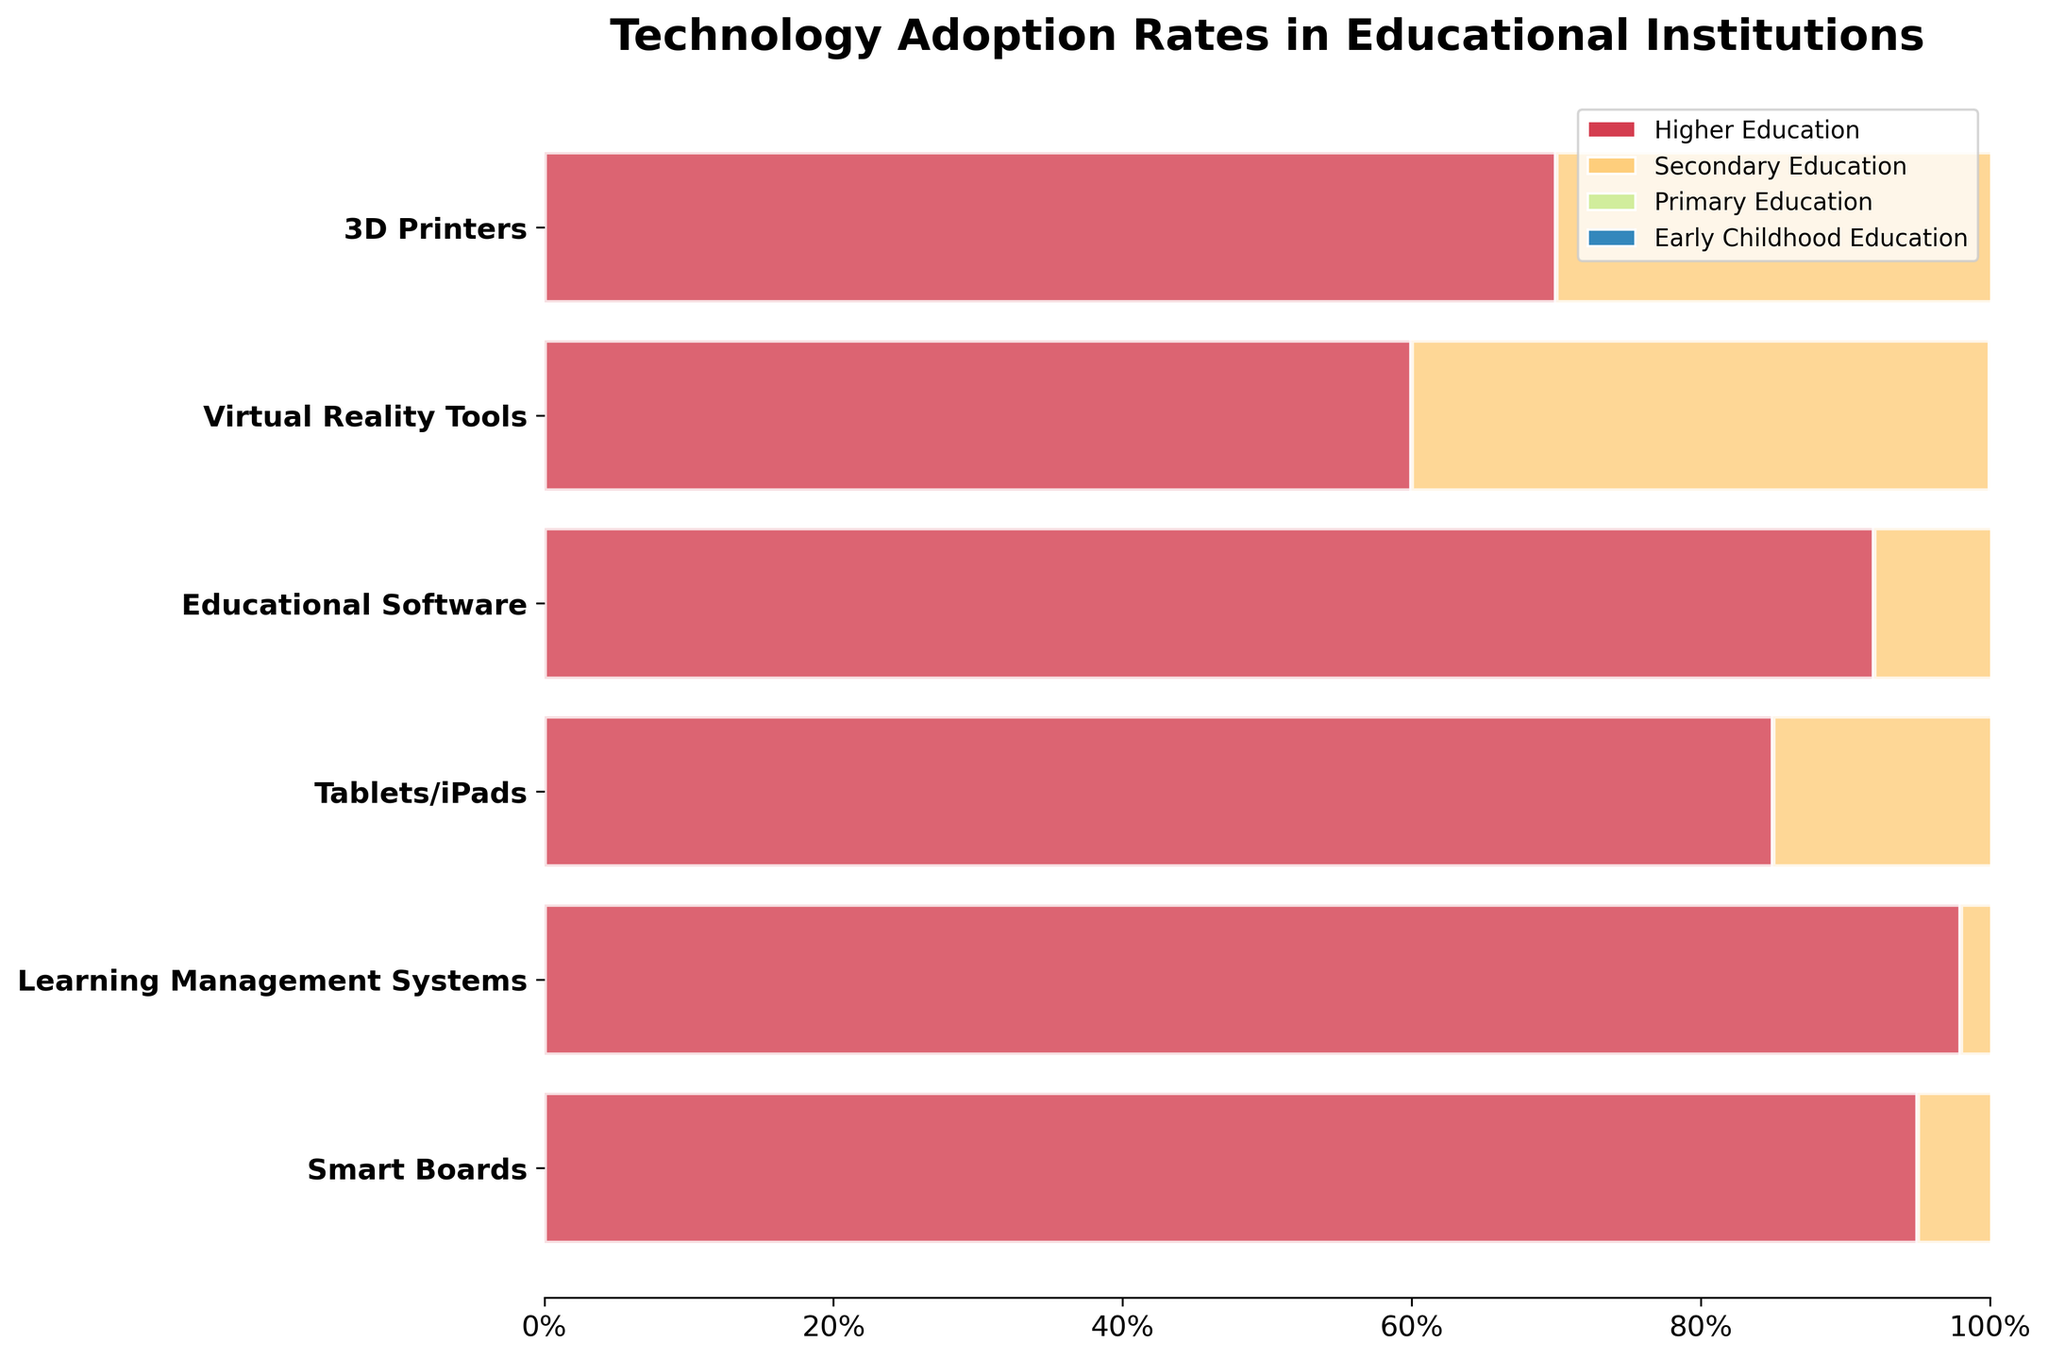What is the title of the Funnel Chart? The title is displayed at the top of the chart in a larger and bold font size. It reads "Technology Adoption Rates in Educational Institutions."
Answer: Technology Adoption Rates in Educational Institutions Which education level shows the highest adoption rate for Smart Boards? Look at the different segments of the Funnel Chart related to Smart Boards. The widest segment or highest percentage represents the highest adoption rate. For Smart Boards, the highest adoption rate is in Higher Education at 95%.
Answer: Higher Education Comparing Smart Boards and Tablets/iPads, which technology has a higher adoption rate in Primary Education? Compare the segments for Smart Boards and Tablets/iPads specifically in Primary Education. Smart Boards have a 65% adoption rate, while Tablets/iPads have a 60% adoption rate in Primary Education.
Answer: Smart Boards How many technologies have more than 50% adoption in Secondary Education? Identify the segments related to Secondary Education and count those with more than 50% adoption. Smart Boards (80%), Learning Management Systems (75%), Tablets/iPads (70%), and Educational Software (85%) are above 50%. That's four technologies in total.
Answer: 4 What is the difference in adoption rates for Virtual Reality Tools between Higher Education and Early Childhood Education? Subtract the adoption rate of Early Childhood Education from Higher Education for Virtual Reality Tools. The adoption rates are 60% for Higher Education and 10% for Early Childhood Education. So, 60% - 10% = 50%.
Answer: 50% Which technology has the lowest adoption rate in Early Childhood Education? Look at the segments specific to Early Childhood Education and identify the one with the smallest width. 3D Printers have the lowest adoption rate at 5%.
Answer: 3D Printers What is the average adoption rate of Tablets/iPads across all education levels? Add the adoption rates of Tablets/iPads across all levels and divide by the number of levels. The rates are 85%, 70%, 60%, and 45%. The sum is 260% and the average is 260% / 4 = 65%.
Answer: 65% 